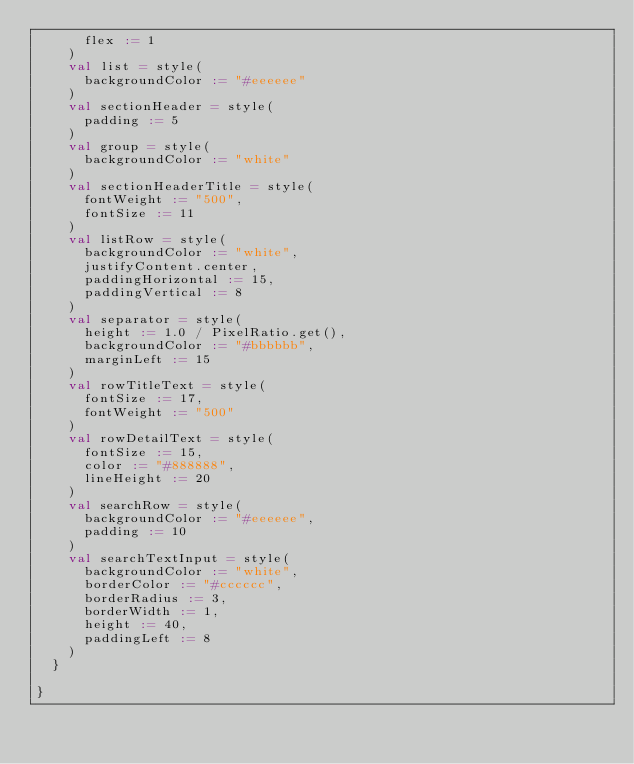<code> <loc_0><loc_0><loc_500><loc_500><_Scala_>      flex := 1
    )
    val list = style(
      backgroundColor := "#eeeeee"
    )
    val sectionHeader = style(
      padding := 5
    )
    val group = style(
      backgroundColor := "white"
    )
    val sectionHeaderTitle = style(
      fontWeight := "500",
      fontSize := 11
    )
    val listRow = style(
      backgroundColor := "white",
      justifyContent.center,
      paddingHorizontal := 15,
      paddingVertical := 8
    )
    val separator = style(
      height := 1.0 / PixelRatio.get(),
      backgroundColor := "#bbbbbb",
      marginLeft := 15
    )
    val rowTitleText = style(
      fontSize := 17,
      fontWeight := "500"
    )
    val rowDetailText = style(
      fontSize := 15,
      color := "#888888",
      lineHeight := 20
    )
    val searchRow = style(
      backgroundColor := "#eeeeee",
      padding := 10
    )
    val searchTextInput = style(
      backgroundColor := "white",
      borderColor := "#cccccc",
      borderRadius := 3,
      borderWidth := 1,
      height := 40,
      paddingLeft := 8
    )
  }

}
</code> 